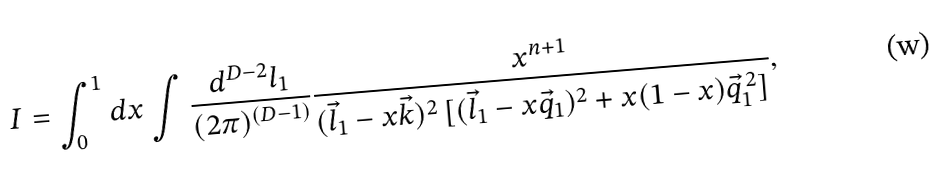Convert formula to latex. <formula><loc_0><loc_0><loc_500><loc_500>I = \int _ { 0 } ^ { 1 } d x \int \frac { d ^ { D - 2 } l _ { 1 } } { ( 2 \pi ) ^ { ( D - 1 ) } } \frac { x ^ { n + 1 } } { ( \vec { l } _ { 1 } - x \vec { k } ) ^ { 2 } \, [ ( \vec { l } _ { 1 } - x \vec { q } _ { 1 } ) ^ { 2 } + x ( 1 - x ) \vec { q } _ { 1 } ^ { \, 2 } ] } ,</formula> 